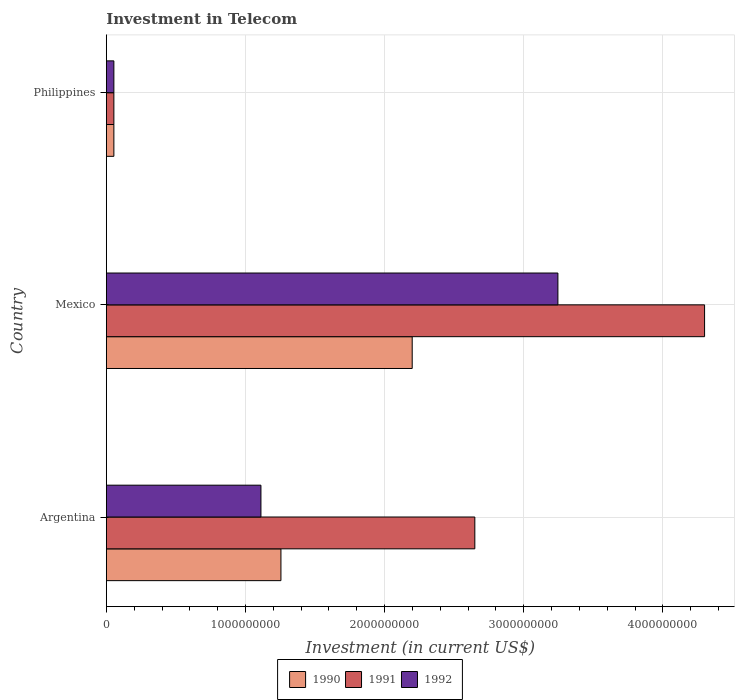How many different coloured bars are there?
Keep it short and to the point. 3. How many groups of bars are there?
Ensure brevity in your answer.  3. What is the label of the 3rd group of bars from the top?
Ensure brevity in your answer.  Argentina. In how many cases, is the number of bars for a given country not equal to the number of legend labels?
Your answer should be very brief. 0. What is the amount invested in telecom in 1990 in Philippines?
Offer a very short reply. 5.42e+07. Across all countries, what is the maximum amount invested in telecom in 1990?
Ensure brevity in your answer.  2.20e+09. Across all countries, what is the minimum amount invested in telecom in 1991?
Your answer should be compact. 5.42e+07. What is the total amount invested in telecom in 1990 in the graph?
Make the answer very short. 3.51e+09. What is the difference between the amount invested in telecom in 1991 in Mexico and that in Philippines?
Keep it short and to the point. 4.24e+09. What is the difference between the amount invested in telecom in 1991 in Argentina and the amount invested in telecom in 1990 in Philippines?
Give a very brief answer. 2.59e+09. What is the average amount invested in telecom in 1990 per country?
Your answer should be very brief. 1.17e+09. What is the difference between the amount invested in telecom in 1990 and amount invested in telecom in 1992 in Argentina?
Your response must be concise. 1.44e+08. In how many countries, is the amount invested in telecom in 1991 greater than 3200000000 US$?
Your answer should be very brief. 1. What is the ratio of the amount invested in telecom in 1990 in Argentina to that in Mexico?
Your answer should be very brief. 0.57. What is the difference between the highest and the second highest amount invested in telecom in 1990?
Provide a succinct answer. 9.43e+08. What is the difference between the highest and the lowest amount invested in telecom in 1990?
Offer a very short reply. 2.14e+09. In how many countries, is the amount invested in telecom in 1991 greater than the average amount invested in telecom in 1991 taken over all countries?
Your response must be concise. 2. What does the 3rd bar from the bottom in Philippines represents?
Your answer should be compact. 1992. Are all the bars in the graph horizontal?
Provide a short and direct response. Yes. Does the graph contain grids?
Your answer should be very brief. Yes. Where does the legend appear in the graph?
Give a very brief answer. Bottom center. How many legend labels are there?
Your answer should be compact. 3. What is the title of the graph?
Keep it short and to the point. Investment in Telecom. What is the label or title of the X-axis?
Provide a short and direct response. Investment (in current US$). What is the Investment (in current US$) in 1990 in Argentina?
Make the answer very short. 1.25e+09. What is the Investment (in current US$) of 1991 in Argentina?
Ensure brevity in your answer.  2.65e+09. What is the Investment (in current US$) in 1992 in Argentina?
Your answer should be compact. 1.11e+09. What is the Investment (in current US$) in 1990 in Mexico?
Offer a terse response. 2.20e+09. What is the Investment (in current US$) in 1991 in Mexico?
Offer a very short reply. 4.30e+09. What is the Investment (in current US$) in 1992 in Mexico?
Give a very brief answer. 3.24e+09. What is the Investment (in current US$) in 1990 in Philippines?
Offer a very short reply. 5.42e+07. What is the Investment (in current US$) in 1991 in Philippines?
Your answer should be very brief. 5.42e+07. What is the Investment (in current US$) of 1992 in Philippines?
Provide a succinct answer. 5.42e+07. Across all countries, what is the maximum Investment (in current US$) in 1990?
Provide a short and direct response. 2.20e+09. Across all countries, what is the maximum Investment (in current US$) of 1991?
Your response must be concise. 4.30e+09. Across all countries, what is the maximum Investment (in current US$) of 1992?
Give a very brief answer. 3.24e+09. Across all countries, what is the minimum Investment (in current US$) in 1990?
Provide a short and direct response. 5.42e+07. Across all countries, what is the minimum Investment (in current US$) of 1991?
Make the answer very short. 5.42e+07. Across all countries, what is the minimum Investment (in current US$) in 1992?
Provide a succinct answer. 5.42e+07. What is the total Investment (in current US$) of 1990 in the graph?
Give a very brief answer. 3.51e+09. What is the total Investment (in current US$) in 1991 in the graph?
Ensure brevity in your answer.  7.00e+09. What is the total Investment (in current US$) in 1992 in the graph?
Offer a terse response. 4.41e+09. What is the difference between the Investment (in current US$) in 1990 in Argentina and that in Mexico?
Ensure brevity in your answer.  -9.43e+08. What is the difference between the Investment (in current US$) of 1991 in Argentina and that in Mexico?
Your response must be concise. -1.65e+09. What is the difference between the Investment (in current US$) in 1992 in Argentina and that in Mexico?
Your response must be concise. -2.13e+09. What is the difference between the Investment (in current US$) in 1990 in Argentina and that in Philippines?
Make the answer very short. 1.20e+09. What is the difference between the Investment (in current US$) in 1991 in Argentina and that in Philippines?
Your answer should be compact. 2.59e+09. What is the difference between the Investment (in current US$) in 1992 in Argentina and that in Philippines?
Your answer should be very brief. 1.06e+09. What is the difference between the Investment (in current US$) in 1990 in Mexico and that in Philippines?
Give a very brief answer. 2.14e+09. What is the difference between the Investment (in current US$) in 1991 in Mexico and that in Philippines?
Your answer should be very brief. 4.24e+09. What is the difference between the Investment (in current US$) of 1992 in Mexico and that in Philippines?
Your response must be concise. 3.19e+09. What is the difference between the Investment (in current US$) in 1990 in Argentina and the Investment (in current US$) in 1991 in Mexico?
Provide a short and direct response. -3.04e+09. What is the difference between the Investment (in current US$) in 1990 in Argentina and the Investment (in current US$) in 1992 in Mexico?
Ensure brevity in your answer.  -1.99e+09. What is the difference between the Investment (in current US$) in 1991 in Argentina and the Investment (in current US$) in 1992 in Mexico?
Ensure brevity in your answer.  -5.97e+08. What is the difference between the Investment (in current US$) in 1990 in Argentina and the Investment (in current US$) in 1991 in Philippines?
Make the answer very short. 1.20e+09. What is the difference between the Investment (in current US$) in 1990 in Argentina and the Investment (in current US$) in 1992 in Philippines?
Your answer should be very brief. 1.20e+09. What is the difference between the Investment (in current US$) in 1991 in Argentina and the Investment (in current US$) in 1992 in Philippines?
Make the answer very short. 2.59e+09. What is the difference between the Investment (in current US$) in 1990 in Mexico and the Investment (in current US$) in 1991 in Philippines?
Provide a succinct answer. 2.14e+09. What is the difference between the Investment (in current US$) of 1990 in Mexico and the Investment (in current US$) of 1992 in Philippines?
Offer a terse response. 2.14e+09. What is the difference between the Investment (in current US$) of 1991 in Mexico and the Investment (in current US$) of 1992 in Philippines?
Keep it short and to the point. 4.24e+09. What is the average Investment (in current US$) of 1990 per country?
Your answer should be very brief. 1.17e+09. What is the average Investment (in current US$) in 1991 per country?
Make the answer very short. 2.33e+09. What is the average Investment (in current US$) of 1992 per country?
Offer a very short reply. 1.47e+09. What is the difference between the Investment (in current US$) of 1990 and Investment (in current US$) of 1991 in Argentina?
Offer a very short reply. -1.39e+09. What is the difference between the Investment (in current US$) of 1990 and Investment (in current US$) of 1992 in Argentina?
Your answer should be compact. 1.44e+08. What is the difference between the Investment (in current US$) in 1991 and Investment (in current US$) in 1992 in Argentina?
Ensure brevity in your answer.  1.54e+09. What is the difference between the Investment (in current US$) in 1990 and Investment (in current US$) in 1991 in Mexico?
Your answer should be compact. -2.10e+09. What is the difference between the Investment (in current US$) of 1990 and Investment (in current US$) of 1992 in Mexico?
Your answer should be very brief. -1.05e+09. What is the difference between the Investment (in current US$) of 1991 and Investment (in current US$) of 1992 in Mexico?
Provide a succinct answer. 1.05e+09. What is the difference between the Investment (in current US$) in 1990 and Investment (in current US$) in 1991 in Philippines?
Ensure brevity in your answer.  0. What is the difference between the Investment (in current US$) in 1990 and Investment (in current US$) in 1992 in Philippines?
Make the answer very short. 0. What is the difference between the Investment (in current US$) of 1991 and Investment (in current US$) of 1992 in Philippines?
Your answer should be compact. 0. What is the ratio of the Investment (in current US$) of 1990 in Argentina to that in Mexico?
Offer a terse response. 0.57. What is the ratio of the Investment (in current US$) of 1991 in Argentina to that in Mexico?
Make the answer very short. 0.62. What is the ratio of the Investment (in current US$) of 1992 in Argentina to that in Mexico?
Ensure brevity in your answer.  0.34. What is the ratio of the Investment (in current US$) in 1990 in Argentina to that in Philippines?
Your response must be concise. 23.15. What is the ratio of the Investment (in current US$) in 1991 in Argentina to that in Philippines?
Provide a succinct answer. 48.86. What is the ratio of the Investment (in current US$) of 1992 in Argentina to that in Philippines?
Give a very brief answer. 20.5. What is the ratio of the Investment (in current US$) in 1990 in Mexico to that in Philippines?
Your answer should be very brief. 40.55. What is the ratio of the Investment (in current US$) in 1991 in Mexico to that in Philippines?
Your answer should be compact. 79.32. What is the ratio of the Investment (in current US$) in 1992 in Mexico to that in Philippines?
Make the answer very short. 59.87. What is the difference between the highest and the second highest Investment (in current US$) in 1990?
Provide a succinct answer. 9.43e+08. What is the difference between the highest and the second highest Investment (in current US$) of 1991?
Provide a succinct answer. 1.65e+09. What is the difference between the highest and the second highest Investment (in current US$) of 1992?
Offer a terse response. 2.13e+09. What is the difference between the highest and the lowest Investment (in current US$) of 1990?
Give a very brief answer. 2.14e+09. What is the difference between the highest and the lowest Investment (in current US$) of 1991?
Offer a very short reply. 4.24e+09. What is the difference between the highest and the lowest Investment (in current US$) in 1992?
Your response must be concise. 3.19e+09. 